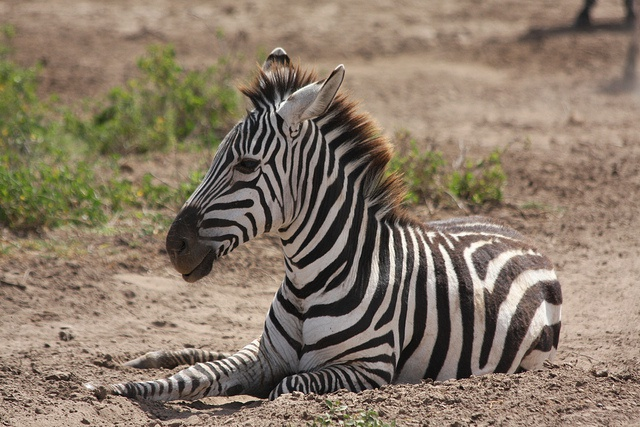Describe the objects in this image and their specific colors. I can see a zebra in gray, black, and darkgray tones in this image. 